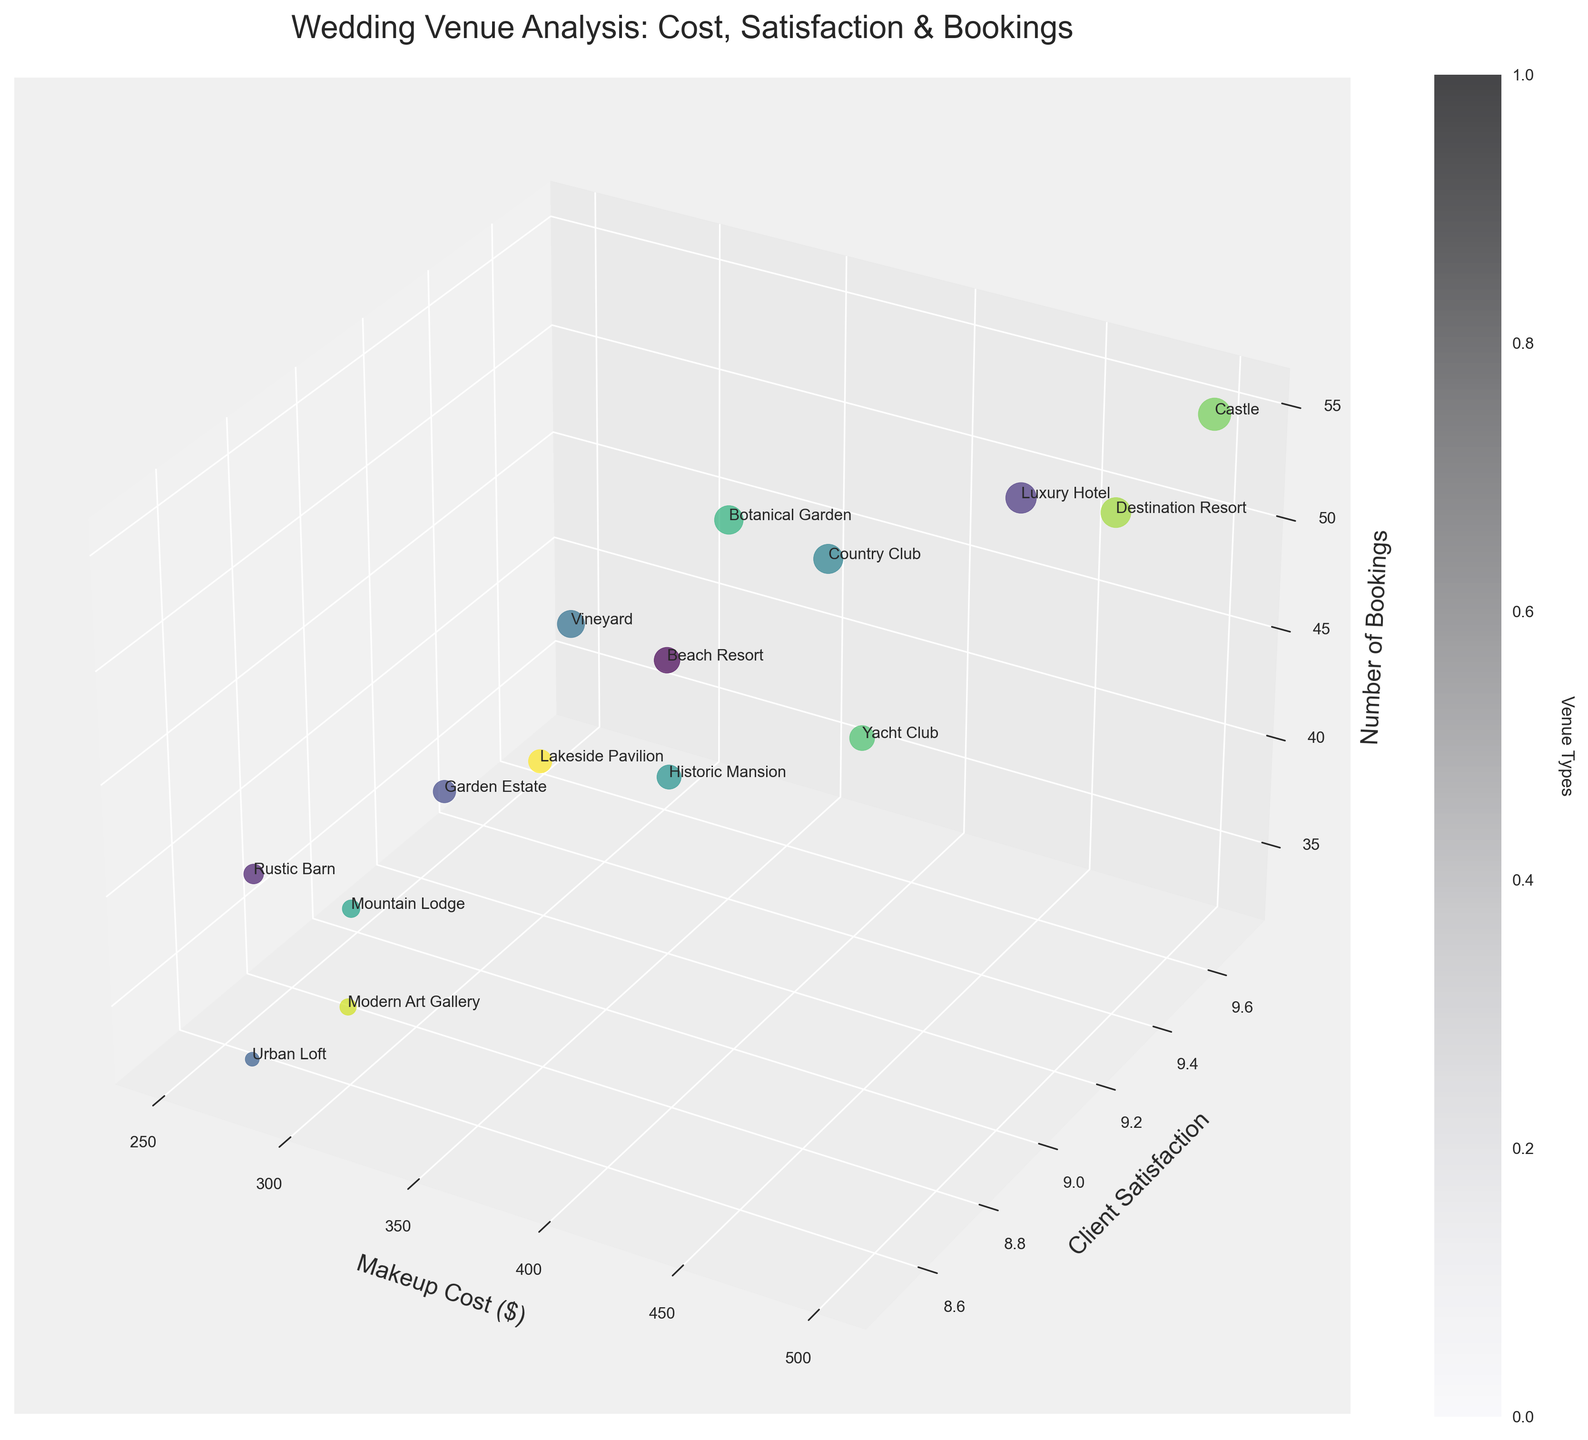What is the title of the figure? The title of a figure is usually located at the top and gives a brief overview of what the chart is about. In this case, it's related to the correlation between wedding venue types, bridal makeup costs, and client satisfaction ratings.
Answer: Wedding Venue Analysis: Cost, Satisfaction & Bookings Which venue type has the highest client satisfaction rating, and what is that rating? By examining the y-axis for the highest point labeled with a venue type name, we can find the highest client satisfaction rating. The Castle has the highest rating at 9.7.
Answer: Castle, 9.7 What is the relationship between makeup cost and client satisfaction for the Castle venue type? To determine this, locate the Castle's label and observe its position along the x-axis (Makeup Cost) and the y-axis (Client Satisfaction). The Castle's makeup cost is $500, and its client satisfaction rating is 9.7. This implies a positive relationship between a higher makeup cost and higher satisfaction for this venue.
Answer: Higher makeup cost, higher satisfaction Comparing Rustic Barn and Urban Loft venue types, which one has higher client satisfaction? By comparing the positions of these two points on the y-axis, we can see which venue type has a higher client satisfaction rating. Rustic Barn has a rating of 8.7, while Urban Loft has 8.5.
Answer: Rustic Barn Which venue type has the largest number of bookings, and what is that figure? In a 3D bubble chart, the size of each bubble often represents the number of bookings. The largest bubble can be identified and its corresponding label can be checked. The Castle has the largest number of bookings, which is 55.
Answer: Castle, 55 What is the average client satisfaction rating across all venue types? To find the average client satisfaction rating, sum all satisfaction ratings and divide by the number of venue types. Here, it would be (9.2 + 8.7 + 9.5 + 8.9 + 8.5 + 9.1 + 9.3 + 9.0 + 8.8 + 9.4 + 9.2 + 9.7 + 9.6 + 8.6 + 9.0) / 15 = 139 / 15 = 9.27.
Answer: 9.27 Is there a trend between makeup costs and client satisfaction ratings across all venues? By generally observing the distribution of the points along the x-axis (Makeup Cost) and y-axis (Client Satisfaction), we can determine any visible trend. There appears to be a loose positive correlation where higher makeup costs are associated with slightly higher client satisfaction.
Answer: Positive correlation Which venue type has the lowest makeup cost, and what is that cost? To find the lowest makeup cost, identify the point that is furthest to the left on the x-axis and check its label. The Rustic Barn has the lowest makeup cost, which is $250.
Answer: Rustic Barn, $250 